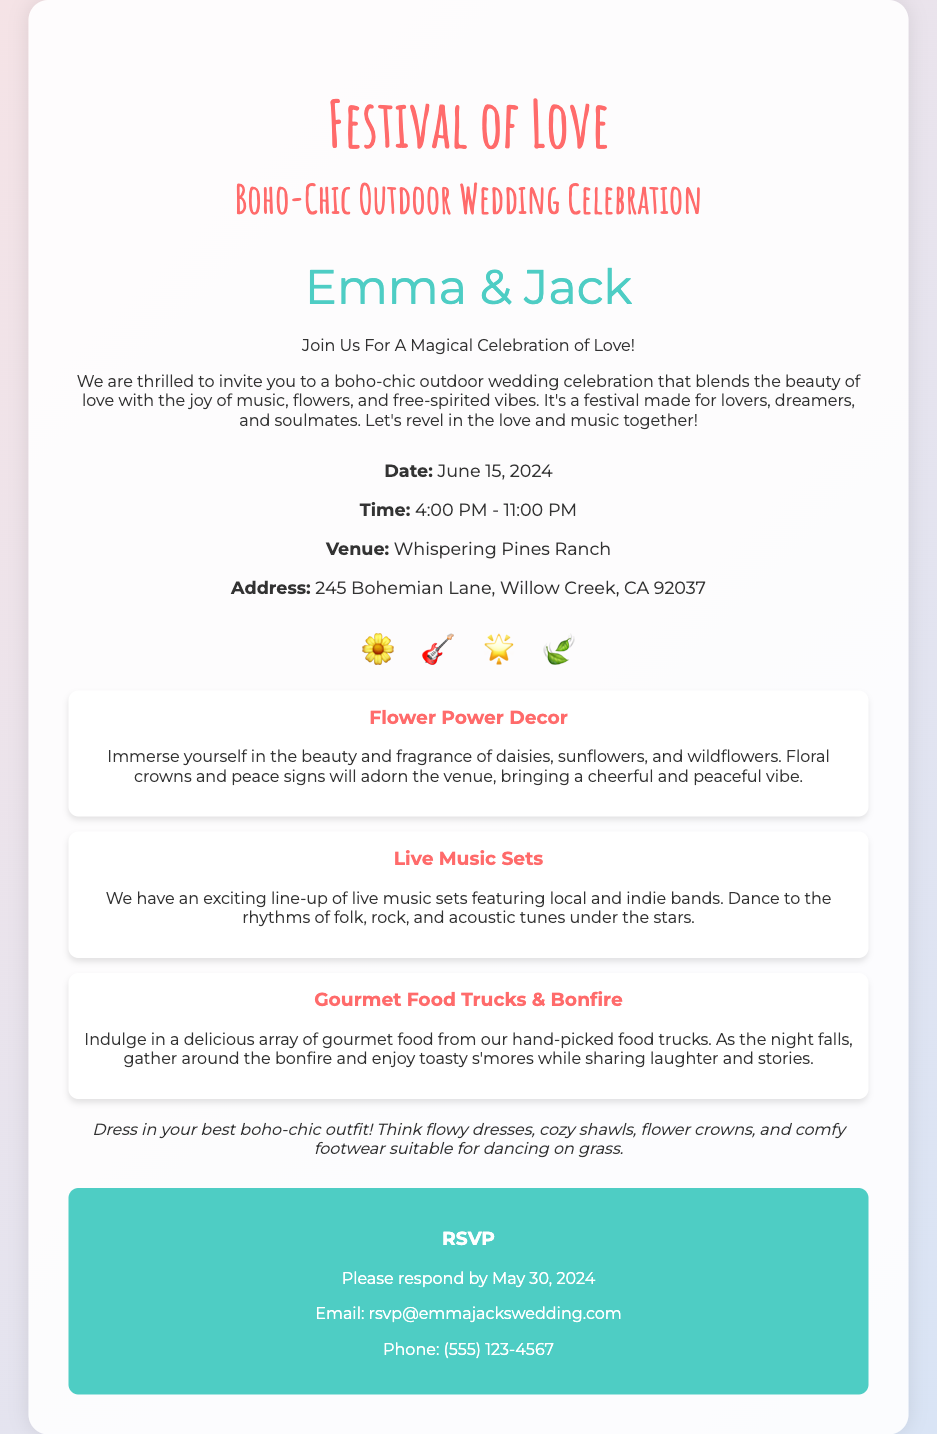What is the date of the wedding? The date is mentioned in the details section of the invitation as June 15, 2024.
Answer: June 15, 2024 What is the venue for the celebration? The venue is specified in the details section as Whispering Pines Ranch.
Answer: Whispering Pines Ranch What time does the wedding celebration start? The starting time is clearly stated in the details section as 4:00 PM.
Answer: 4:00 PM Who are the couple getting married? The names of the couple are highlighted prominently as Emma and Jack.
Answer: Emma & Jack What type of decor is featured at the wedding? The invitation mentions "Flower Power Decor" which includes flowers like daisies and sunflowers.
Answer: Flower Power Decor What is suggested for guest attire? The invitation specifically advises guests to dress in their best boho-chic outfit with flowy dresses and flower crowns.
Answer: boho-chic outfit What type of food will be available at the wedding? The invitation mentions "Gourmet Food Trucks" that will offer a delicious array of food.
Answer: Gourmet Food Trucks When is the RSVP deadline? The deadline for RSVPs is provided in the RSVP section as May 30, 2024.
Answer: May 30, 2024 What activities will guests be able to enjoy? The invitation highlights "Live Music Sets," "Gourmet Food Trucks," and a "Bonfire" for entertainment.
Answer: Live Music Sets, Gourmet Food Trucks, Bonfire 